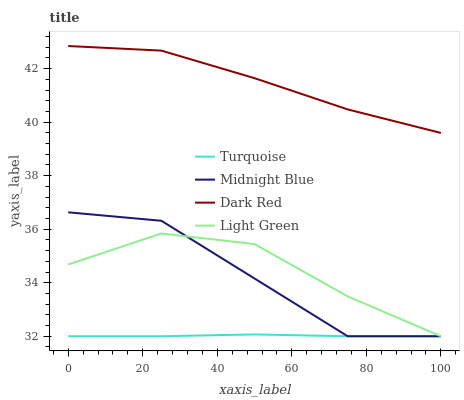Does Midnight Blue have the minimum area under the curve?
Answer yes or no. No. Does Midnight Blue have the maximum area under the curve?
Answer yes or no. No. Is Midnight Blue the smoothest?
Answer yes or no. No. Is Turquoise the roughest?
Answer yes or no. No. Does Midnight Blue have the highest value?
Answer yes or no. No. Is Light Green less than Dark Red?
Answer yes or no. Yes. Is Dark Red greater than Light Green?
Answer yes or no. Yes. Does Light Green intersect Dark Red?
Answer yes or no. No. 